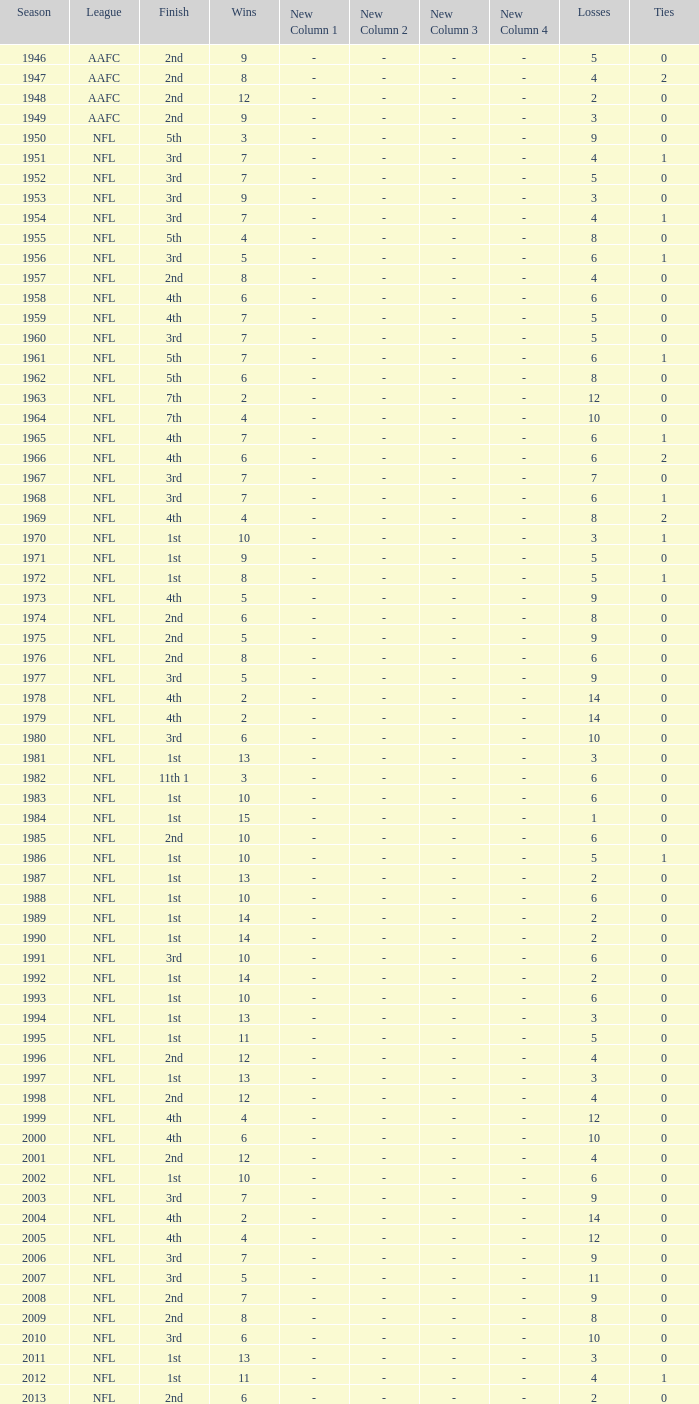What is the number of losses when the ties are lesser than 0? 0.0. 